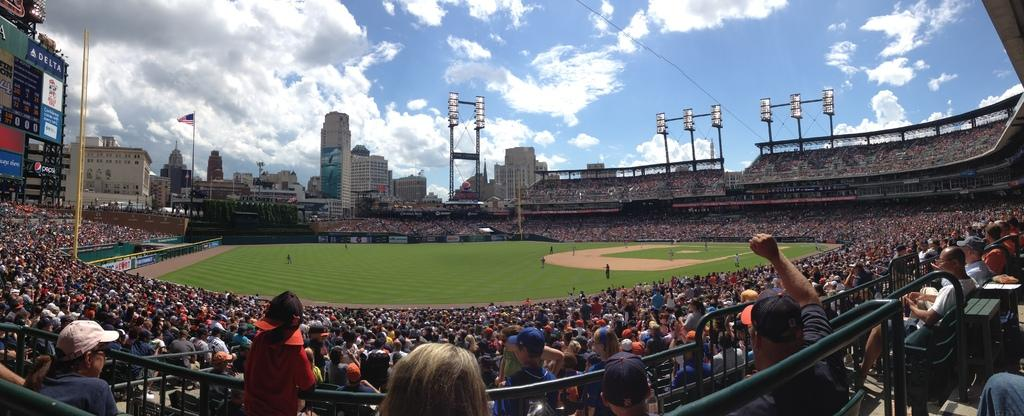What type of structure is the main subject of the image? There is a stadium in the image. What can be found on the field inside the stadium? There is grassland in the stadium. Are there any people present in the image? Yes, there are people in the stadium. What features can be seen in the stadium to define its boundaries? There are boundaries in the stadium. What type of signage is present in the image? There are posters in the stadium. What other structures can be seen in the image? There are poles in the stadium and buildings visible in the image. What is visible in the sky in the image? The sky is visible in the image. What type of meat is being served in the stocking on the pole in the image? There is no stocking, meat, or pole present in the image. 